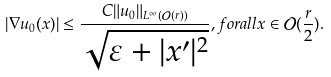Convert formula to latex. <formula><loc_0><loc_0><loc_500><loc_500>| \nabla u _ { 0 } ( x ) | \leq \frac { C \| u _ { 0 } \| _ { L ^ { \infty } ( \mathcal { O } ( r ) ) } } { \sqrt { \varepsilon + | x ^ { \prime } | ^ { 2 } } } , f o r a l l x \in \mathcal { O } ( \frac { r } { 2 } ) .</formula> 